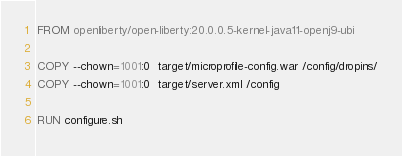Convert code to text. <code><loc_0><loc_0><loc_500><loc_500><_Dockerfile_>FROM openliberty/open-liberty:20.0.0.5-kernel-java11-openj9-ubi

COPY --chown=1001:0  target/microprofile-config.war /config/dropins/
COPY --chown=1001:0  target/server.xml /config

RUN configure.sh
</code> 